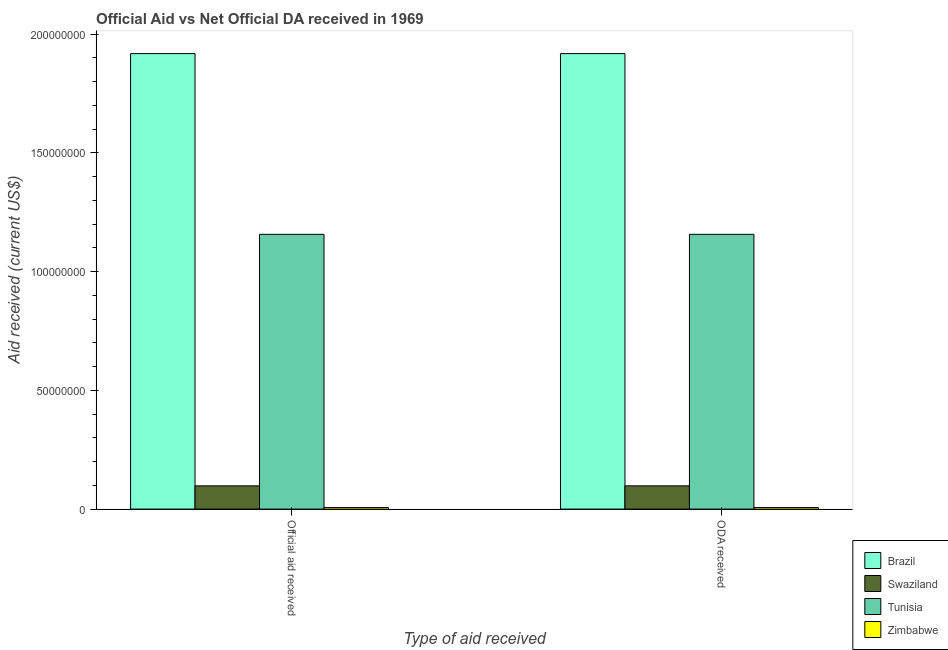How many different coloured bars are there?
Make the answer very short. 4. How many bars are there on the 2nd tick from the left?
Your answer should be compact. 4. What is the label of the 1st group of bars from the left?
Make the answer very short. Official aid received. What is the oda received in Brazil?
Provide a succinct answer. 1.92e+08. Across all countries, what is the maximum oda received?
Offer a very short reply. 1.92e+08. Across all countries, what is the minimum oda received?
Ensure brevity in your answer.  6.50e+05. In which country was the oda received maximum?
Your answer should be very brief. Brazil. In which country was the official aid received minimum?
Provide a succinct answer. Zimbabwe. What is the total oda received in the graph?
Make the answer very short. 3.18e+08. What is the difference between the oda received in Swaziland and that in Zimbabwe?
Give a very brief answer. 9.14e+06. What is the difference between the official aid received in Brazil and the oda received in Swaziland?
Provide a short and direct response. 1.82e+08. What is the average oda received per country?
Ensure brevity in your answer.  7.95e+07. In how many countries, is the oda received greater than 170000000 US$?
Your answer should be very brief. 1. What is the ratio of the official aid received in Swaziland to that in Tunisia?
Your answer should be compact. 0.08. In how many countries, is the oda received greater than the average oda received taken over all countries?
Make the answer very short. 2. What does the 4th bar from the left in ODA received represents?
Provide a short and direct response. Zimbabwe. What does the 4th bar from the right in ODA received represents?
Offer a terse response. Brazil. Are all the bars in the graph horizontal?
Ensure brevity in your answer.  No. What is the difference between two consecutive major ticks on the Y-axis?
Give a very brief answer. 5.00e+07. Does the graph contain any zero values?
Provide a succinct answer. No. Does the graph contain grids?
Ensure brevity in your answer.  No. What is the title of the graph?
Provide a short and direct response. Official Aid vs Net Official DA received in 1969 . Does "Mauritius" appear as one of the legend labels in the graph?
Provide a succinct answer. No. What is the label or title of the X-axis?
Your answer should be compact. Type of aid received. What is the label or title of the Y-axis?
Your answer should be very brief. Aid received (current US$). What is the Aid received (current US$) of Brazil in Official aid received?
Your answer should be compact. 1.92e+08. What is the Aid received (current US$) in Swaziland in Official aid received?
Give a very brief answer. 9.79e+06. What is the Aid received (current US$) in Tunisia in Official aid received?
Offer a terse response. 1.16e+08. What is the Aid received (current US$) in Zimbabwe in Official aid received?
Offer a very short reply. 6.50e+05. What is the Aid received (current US$) in Brazil in ODA received?
Provide a succinct answer. 1.92e+08. What is the Aid received (current US$) of Swaziland in ODA received?
Keep it short and to the point. 9.79e+06. What is the Aid received (current US$) in Tunisia in ODA received?
Your response must be concise. 1.16e+08. What is the Aid received (current US$) in Zimbabwe in ODA received?
Make the answer very short. 6.50e+05. Across all Type of aid received, what is the maximum Aid received (current US$) of Brazil?
Ensure brevity in your answer.  1.92e+08. Across all Type of aid received, what is the maximum Aid received (current US$) in Swaziland?
Your answer should be compact. 9.79e+06. Across all Type of aid received, what is the maximum Aid received (current US$) in Tunisia?
Make the answer very short. 1.16e+08. Across all Type of aid received, what is the maximum Aid received (current US$) in Zimbabwe?
Provide a short and direct response. 6.50e+05. Across all Type of aid received, what is the minimum Aid received (current US$) in Brazil?
Give a very brief answer. 1.92e+08. Across all Type of aid received, what is the minimum Aid received (current US$) in Swaziland?
Keep it short and to the point. 9.79e+06. Across all Type of aid received, what is the minimum Aid received (current US$) of Tunisia?
Keep it short and to the point. 1.16e+08. Across all Type of aid received, what is the minimum Aid received (current US$) in Zimbabwe?
Offer a very short reply. 6.50e+05. What is the total Aid received (current US$) in Brazil in the graph?
Your answer should be compact. 3.84e+08. What is the total Aid received (current US$) of Swaziland in the graph?
Ensure brevity in your answer.  1.96e+07. What is the total Aid received (current US$) of Tunisia in the graph?
Your answer should be compact. 2.31e+08. What is the total Aid received (current US$) in Zimbabwe in the graph?
Ensure brevity in your answer.  1.30e+06. What is the difference between the Aid received (current US$) of Brazil in Official aid received and that in ODA received?
Make the answer very short. 0. What is the difference between the Aid received (current US$) in Brazil in Official aid received and the Aid received (current US$) in Swaziland in ODA received?
Make the answer very short. 1.82e+08. What is the difference between the Aid received (current US$) in Brazil in Official aid received and the Aid received (current US$) in Tunisia in ODA received?
Offer a very short reply. 7.61e+07. What is the difference between the Aid received (current US$) of Brazil in Official aid received and the Aid received (current US$) of Zimbabwe in ODA received?
Provide a succinct answer. 1.91e+08. What is the difference between the Aid received (current US$) in Swaziland in Official aid received and the Aid received (current US$) in Tunisia in ODA received?
Your answer should be compact. -1.06e+08. What is the difference between the Aid received (current US$) of Swaziland in Official aid received and the Aid received (current US$) of Zimbabwe in ODA received?
Your response must be concise. 9.14e+06. What is the difference between the Aid received (current US$) of Tunisia in Official aid received and the Aid received (current US$) of Zimbabwe in ODA received?
Your answer should be compact. 1.15e+08. What is the average Aid received (current US$) in Brazil per Type of aid received?
Ensure brevity in your answer.  1.92e+08. What is the average Aid received (current US$) in Swaziland per Type of aid received?
Offer a terse response. 9.79e+06. What is the average Aid received (current US$) of Tunisia per Type of aid received?
Your answer should be very brief. 1.16e+08. What is the average Aid received (current US$) of Zimbabwe per Type of aid received?
Make the answer very short. 6.50e+05. What is the difference between the Aid received (current US$) in Brazil and Aid received (current US$) in Swaziland in Official aid received?
Ensure brevity in your answer.  1.82e+08. What is the difference between the Aid received (current US$) of Brazil and Aid received (current US$) of Tunisia in Official aid received?
Ensure brevity in your answer.  7.61e+07. What is the difference between the Aid received (current US$) of Brazil and Aid received (current US$) of Zimbabwe in Official aid received?
Make the answer very short. 1.91e+08. What is the difference between the Aid received (current US$) of Swaziland and Aid received (current US$) of Tunisia in Official aid received?
Offer a terse response. -1.06e+08. What is the difference between the Aid received (current US$) in Swaziland and Aid received (current US$) in Zimbabwe in Official aid received?
Ensure brevity in your answer.  9.14e+06. What is the difference between the Aid received (current US$) in Tunisia and Aid received (current US$) in Zimbabwe in Official aid received?
Provide a succinct answer. 1.15e+08. What is the difference between the Aid received (current US$) of Brazil and Aid received (current US$) of Swaziland in ODA received?
Offer a very short reply. 1.82e+08. What is the difference between the Aid received (current US$) of Brazil and Aid received (current US$) of Tunisia in ODA received?
Make the answer very short. 7.61e+07. What is the difference between the Aid received (current US$) in Brazil and Aid received (current US$) in Zimbabwe in ODA received?
Provide a short and direct response. 1.91e+08. What is the difference between the Aid received (current US$) in Swaziland and Aid received (current US$) in Tunisia in ODA received?
Your answer should be compact. -1.06e+08. What is the difference between the Aid received (current US$) of Swaziland and Aid received (current US$) of Zimbabwe in ODA received?
Make the answer very short. 9.14e+06. What is the difference between the Aid received (current US$) in Tunisia and Aid received (current US$) in Zimbabwe in ODA received?
Provide a succinct answer. 1.15e+08. What is the ratio of the Aid received (current US$) in Brazil in Official aid received to that in ODA received?
Your answer should be very brief. 1. What is the ratio of the Aid received (current US$) in Tunisia in Official aid received to that in ODA received?
Offer a very short reply. 1. What is the difference between the highest and the second highest Aid received (current US$) in Zimbabwe?
Offer a terse response. 0. What is the difference between the highest and the lowest Aid received (current US$) of Swaziland?
Offer a very short reply. 0. 